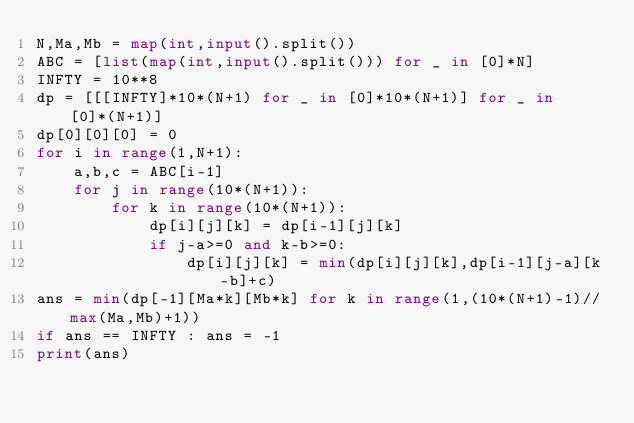Convert code to text. <code><loc_0><loc_0><loc_500><loc_500><_Python_>N,Ma,Mb = map(int,input().split())
ABC = [list(map(int,input().split())) for _ in [0]*N]
INFTY = 10**8
dp = [[[INFTY]*10*(N+1) for _ in [0]*10*(N+1)] for _ in [0]*(N+1)]
dp[0][0][0] = 0
for i in range(1,N+1):
    a,b,c = ABC[i-1]
    for j in range(10*(N+1)):
        for k in range(10*(N+1)):
            dp[i][j][k] = dp[i-1][j][k]
            if j-a>=0 and k-b>=0:
                dp[i][j][k] = min(dp[i][j][k],dp[i-1][j-a][k-b]+c)
ans = min(dp[-1][Ma*k][Mb*k] for k in range(1,(10*(N+1)-1)//max(Ma,Mb)+1))
if ans == INFTY : ans = -1
print(ans)</code> 